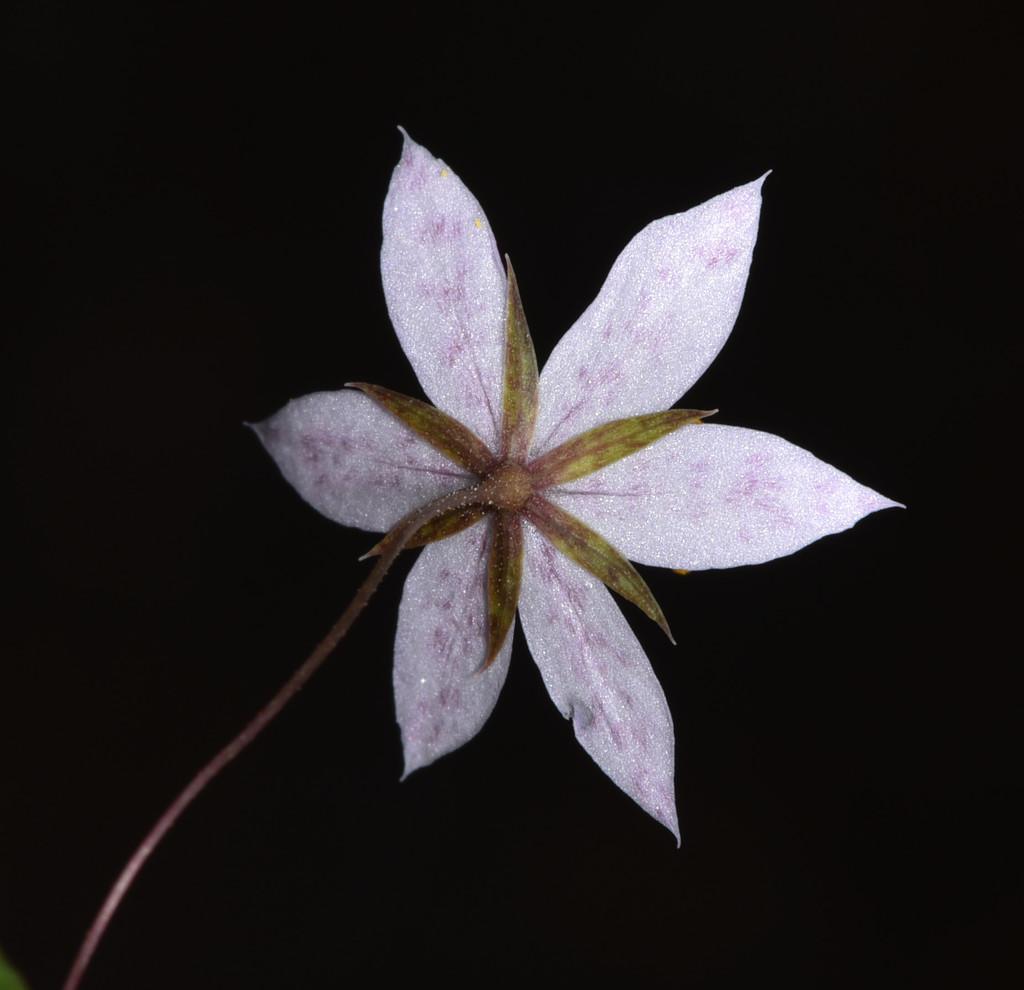How would you summarize this image in a sentence or two? In the middle of the image there is a flower with petals and stem. The flower is light pink in color. In this image the background is dark. 